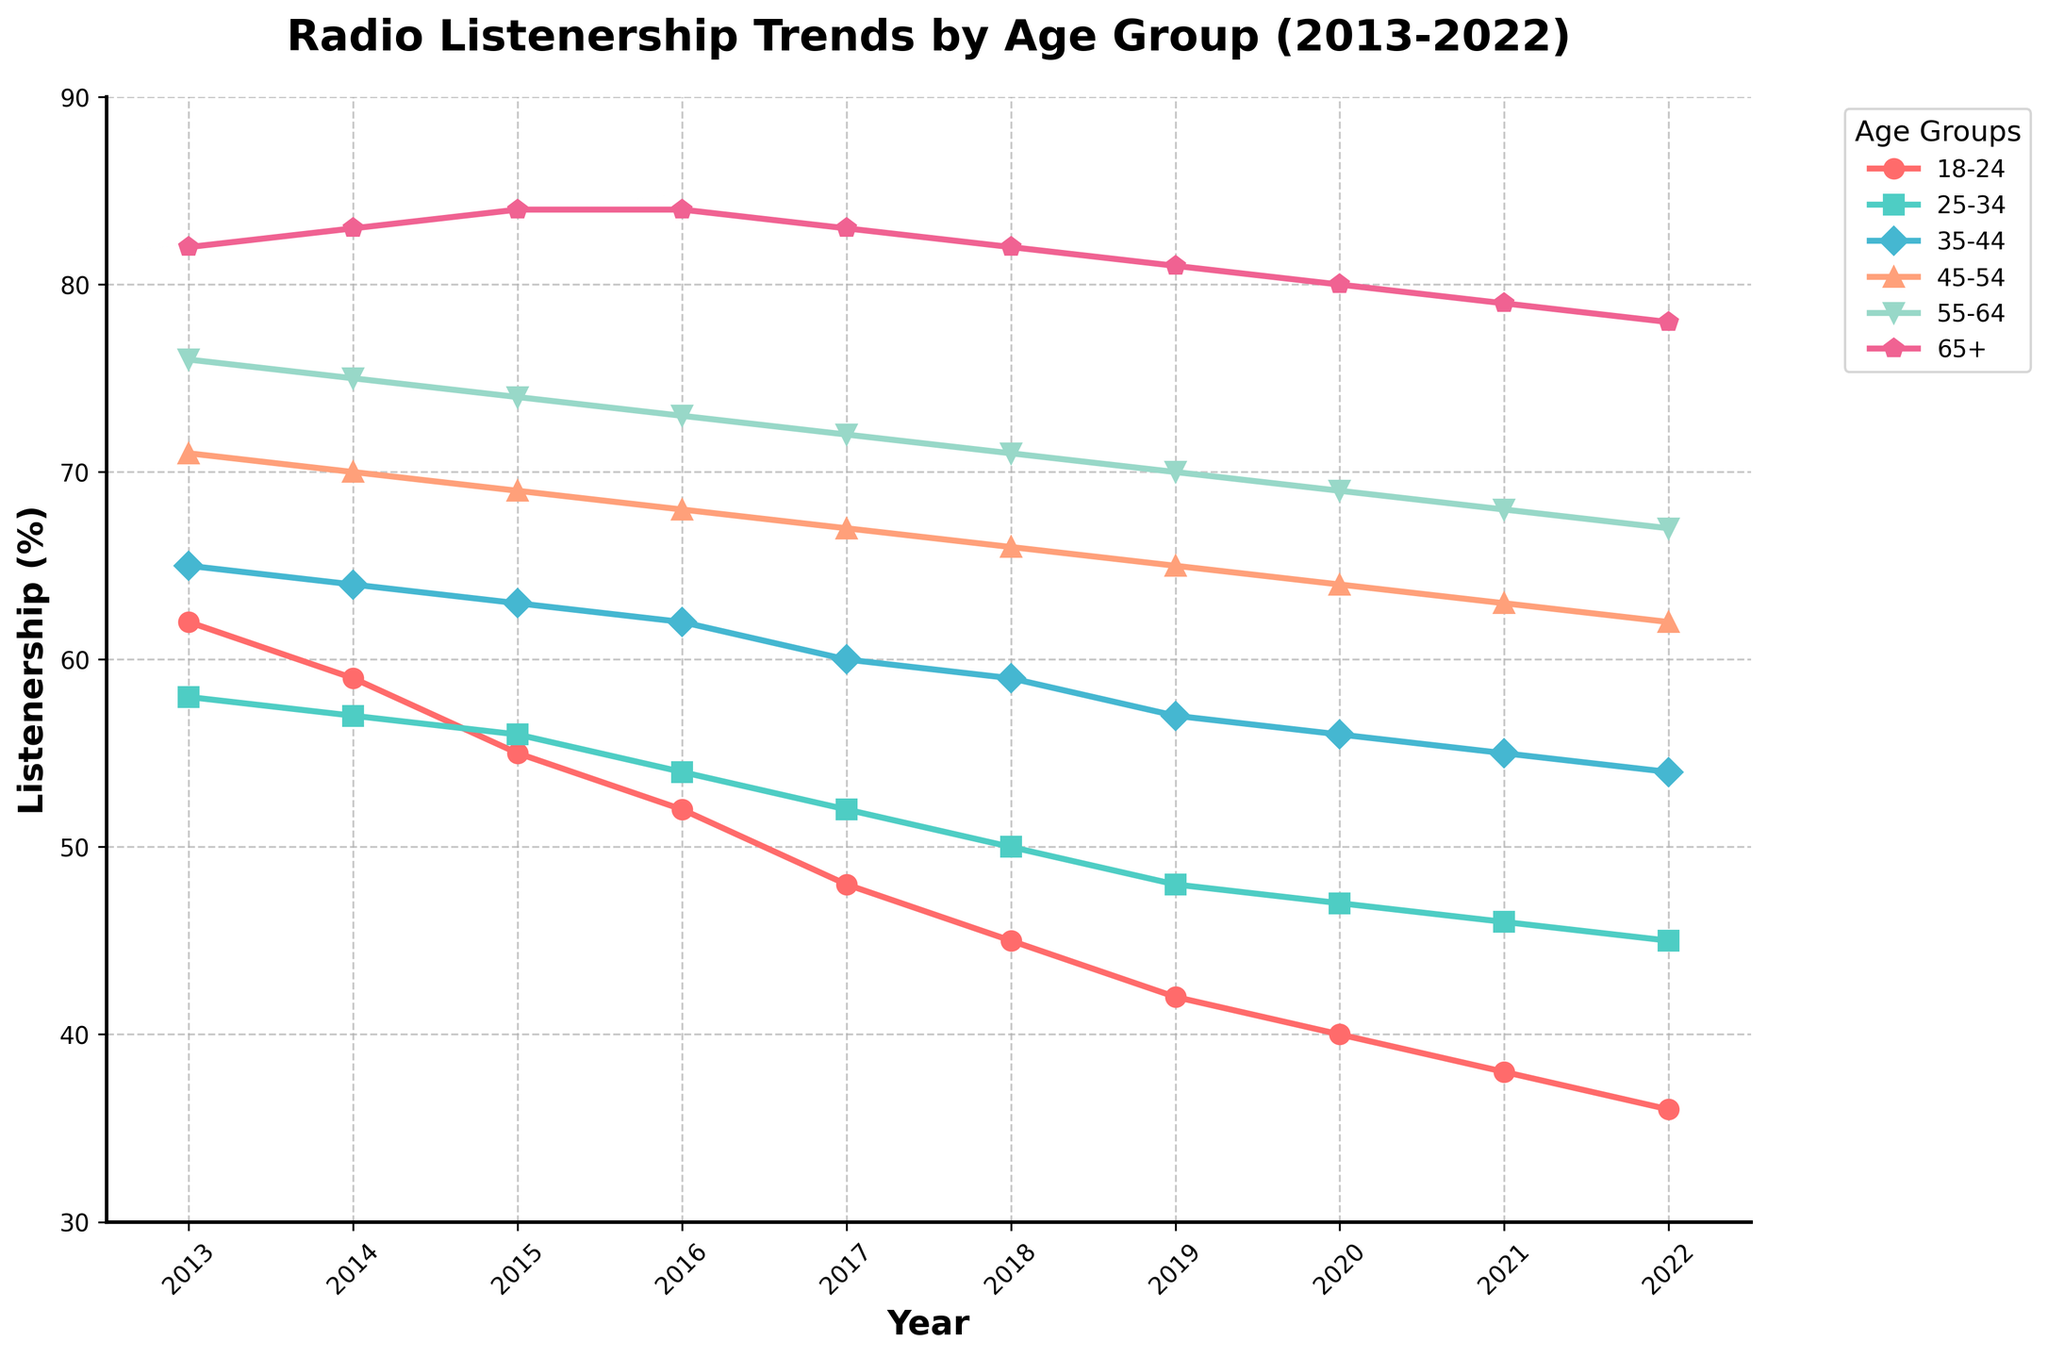What is the trend in radio listenership for the 18-24 age group from 2013 to 2022? The listenership for the 18-24 age group consistently declines each year from 62% in 2013 to 36% in 2022 as observed from the downward slope of the line.
Answer: Declining Comparing 2013 and 2022, which age group shows the least decline in radio listenership? From the figure, the 65+ age group shows the smallest decline, going from 82% in 2013 to 78% in 2022, reflecting only a 4% decrease.
Answer: 65+ Which age group had the highest listenership in 2017? In 2017, the age group 65+ had the highest listenership at 83%, based on the highest point reached by any line in that year.
Answer: 65+ What is the average listenership for the 35-44 age group over the entire period? The average is obtained by summing the listenership percentages for the 35-44 age group from 2013 to 2022 and dividing by the number of years. Calculation: (65 + 64 + 63 + 62 + 60 + 59 + 57 + 56 + 55 + 54) / 10 = 59.5
Answer: 59.5% In which year was the listenership of the 45-54 age group equal to the 55-64 age group? By visually inspecting the lines for the 45-54 and 55-64 age groups, it can be observed that these two lines intersect in the year 2021.
Answer: 2021 Which age group experienced the steepest percentage decline in radio listenership from 2013 to 2022? By comparing the initial and final percentages, the 18-24 age group experienced the steepest decline, decreasing from 62% in 2013 to 36% in 2022, which is a 26% drop.
Answer: 18-24 Between 2019 and 2020, which age group had the smallest decline in listenership? Between 2019 and 2020, the smallest decline is observed in the 65+ age group, which declined by 1% from 81% to 80%.
Answer: 65+ How does the gap between the highest and lowest age group's listenership change from 2013 to 2022? In 2013, the gap between the highest and lowest age groups (18-24 and 65+) is 82% - 62% = 20%. In 2022, the gap is 78% - 36% = 42%. Thus, the gap increased by 22%.
Answer: Increased by 22% Which year shows the most significant drop in listenership for the 25-34 age group? The biggest single-year drop for the 25-34 age group occurs between 2014 and 2015, where listenership falls from 57% to 56%, a decrease of 1%.
Answer: 2014-2015 